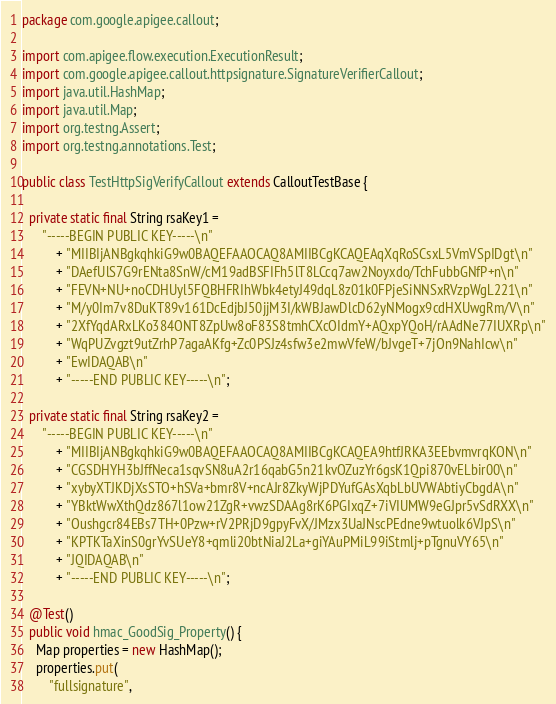Convert code to text. <code><loc_0><loc_0><loc_500><loc_500><_Java_>package com.google.apigee.callout;

import com.apigee.flow.execution.ExecutionResult;
import com.google.apigee.callout.httpsignature.SignatureVerifierCallout;
import java.util.HashMap;
import java.util.Map;
import org.testng.Assert;
import org.testng.annotations.Test;

public class TestHttpSigVerifyCallout extends CalloutTestBase {

  private static final String rsaKey1 =
      "-----BEGIN PUBLIC KEY-----\n"
          + "MIIBIjANBgkqhkiG9w0BAQEFAAOCAQ8AMIIBCgKCAQEAqXqRoSCsxL5VmVSpIDgt\n"
          + "DAefUlS7G9rENta8SnW/cM19adBSFIFh5lT8LCcq7aw2Noyxdo/TchFubbGNfP+n\n"
          + "FEVN+NU+noCDHUyl5FQBHFRIhWbk4etyJ49dqL8z01k0FPjeSiNNSxRVzpWgL221\n"
          + "M/y0Im7v8DuKT89v161DcEdjbJ50jjM3I/kWBJawDlcD62yNMogx9cdHXUwgRm/V\n"
          + "2XfYqdARxLKo384ONT8ZpUw8oF83S8tmhCXcOIdmY+AQxpYQoH/rAAdNe77IUXRp\n"
          + "WqPUZvgzt9utZrhP7agaAKfg+Zc0PSJz4sfw3e2mwVfeW/bJvgeT+7jOn9NahIcw\n"
          + "EwIDAQAB\n"
          + "-----END PUBLIC KEY-----\n";

  private static final String rsaKey2 =
      "-----BEGIN PUBLIC KEY-----\n"
          + "MIIBIjANBgkqhkiG9w0BAQEFAAOCAQ8AMIIBCgKCAQEA9htfJRKA3EEbvmvrqKON\n"
          + "CGSDHYH3bJffNeca1sqvSN8uA2r16qabG5n21kvOZuzYr6gsK1Qpi870vELbir00\n"
          + "xybyXTJKDjXsSTO+hSVa+bmr8V+ncAJr8ZkyWjPDYufGAsXqbLbUVWAbtiyCbgdA\n"
          + "YBktWwXthQdz867l1ow21ZgR+vwzSDAAg8rK6PGIxqZ+7iVIUMW9eGJpr5vSdRXX\n"
          + "Oushgcr84EBs7TH+0Pzw+rV2PRjD9gpyFvX/JMzx3UaJNscPEdne9wtuolk6VJpS\n"
          + "KPTKTaXinS0grYvSUeY8+qmli20btNiaJ2La+giYAuPMiL99iStmlj+pTgnuVY65\n"
          + "JQIDAQAB\n"
          + "-----END PUBLIC KEY-----\n";

  @Test()
  public void hmac_GoodSig_Property() {
    Map properties = new HashMap();
    properties.put(
        "fullsignature",</code> 